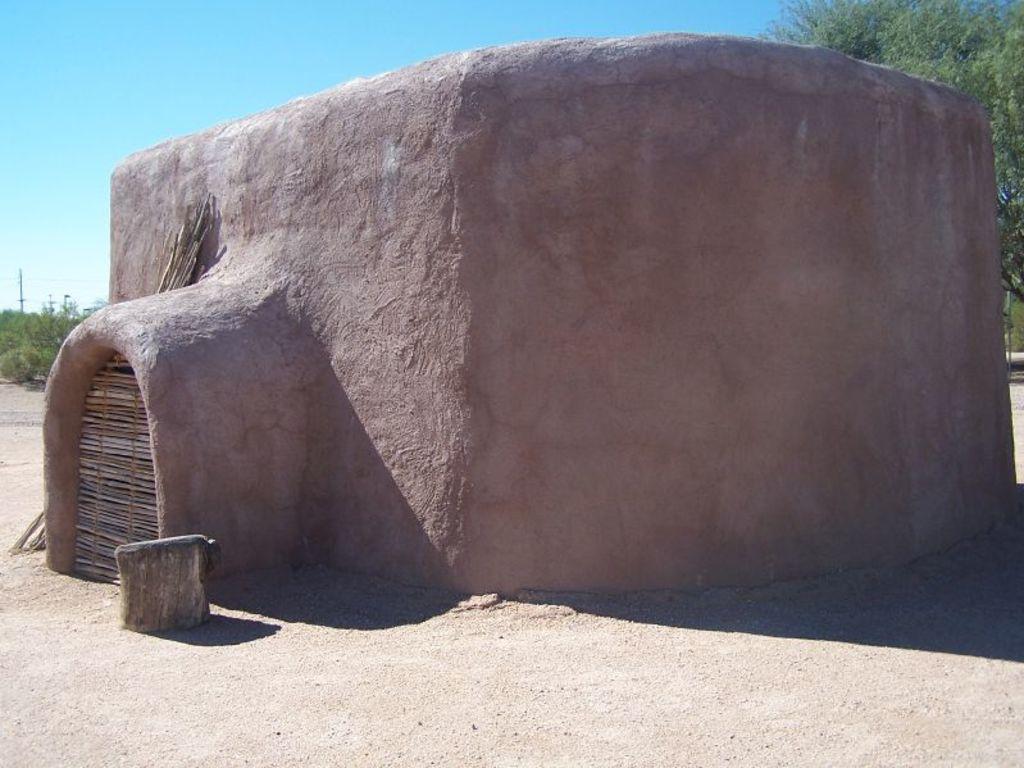Can you describe this image briefly? I this image in the center there is one house, at the bottom there is sand and in the background there are some trees and sky. 